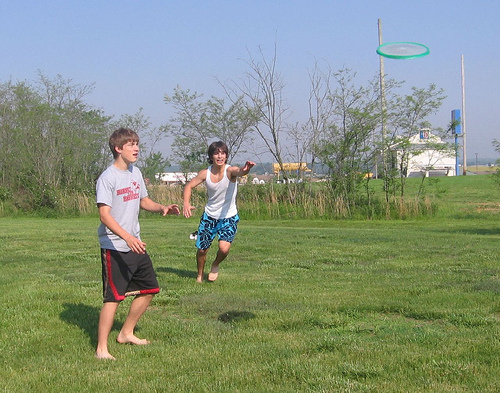<image>What brand is on the boy's shirt? It is ambiguous what brand is on the boy's shirt. It could be 'nike', 'adidas', or 'puma', but it is not clearly visible. What brand is on the boy's shirt? I am not sure what brand is on the boy's shirt. It can be seen 'nike', 'adidas', 'puma' or other brand. 